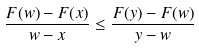<formula> <loc_0><loc_0><loc_500><loc_500>\frac { F ( w ) - F ( x ) } { w - x } \leq \frac { F ( y ) - F ( w ) } { y - w }</formula> 